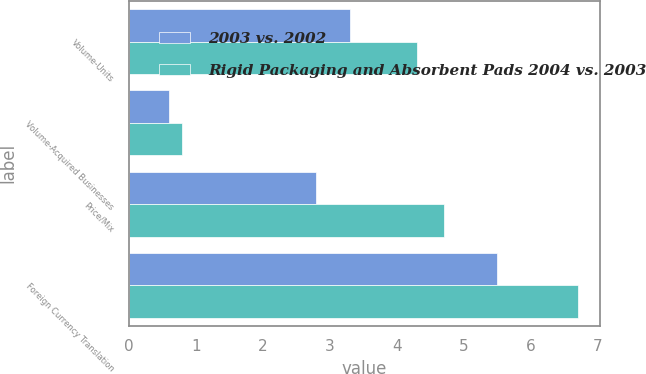<chart> <loc_0><loc_0><loc_500><loc_500><stacked_bar_chart><ecel><fcel>Volume-Units<fcel>Volume-Acquired Businesses<fcel>Price/Mix<fcel>Foreign Currency Translation<nl><fcel>2003 vs. 2002<fcel>3.3<fcel>0.6<fcel>2.8<fcel>5.5<nl><fcel>Rigid Packaging and Absorbent Pads 2004 vs. 2003<fcel>4.3<fcel>0.8<fcel>4.7<fcel>6.7<nl></chart> 